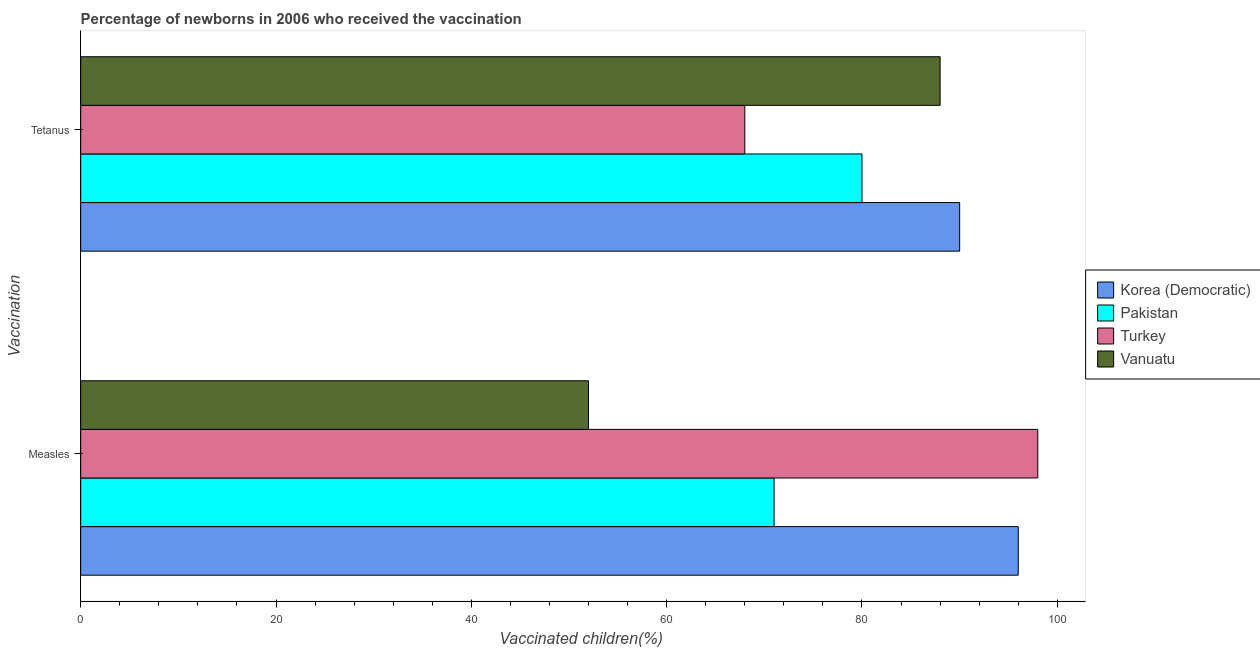How many different coloured bars are there?
Keep it short and to the point. 4. How many groups of bars are there?
Offer a very short reply. 2. How many bars are there on the 1st tick from the top?
Keep it short and to the point. 4. What is the label of the 1st group of bars from the top?
Make the answer very short. Tetanus. What is the percentage of newborns who received vaccination for measles in Korea (Democratic)?
Keep it short and to the point. 96. Across all countries, what is the maximum percentage of newborns who received vaccination for tetanus?
Your response must be concise. 90. Across all countries, what is the minimum percentage of newborns who received vaccination for tetanus?
Provide a short and direct response. 68. In which country was the percentage of newborns who received vaccination for tetanus maximum?
Make the answer very short. Korea (Democratic). What is the total percentage of newborns who received vaccination for tetanus in the graph?
Offer a terse response. 326. What is the difference between the percentage of newborns who received vaccination for measles in Vanuatu and that in Korea (Democratic)?
Provide a short and direct response. -44. What is the difference between the percentage of newborns who received vaccination for tetanus in Vanuatu and the percentage of newborns who received vaccination for measles in Pakistan?
Your answer should be compact. 17. What is the average percentage of newborns who received vaccination for tetanus per country?
Offer a very short reply. 81.5. What is the difference between the percentage of newborns who received vaccination for tetanus and percentage of newborns who received vaccination for measles in Vanuatu?
Make the answer very short. 36. In how many countries, is the percentage of newborns who received vaccination for measles greater than 84 %?
Your answer should be very brief. 2. What is the ratio of the percentage of newborns who received vaccination for measles in Pakistan to that in Turkey?
Offer a very short reply. 0.72. Is the percentage of newborns who received vaccination for measles in Turkey less than that in Korea (Democratic)?
Give a very brief answer. No. In how many countries, is the percentage of newborns who received vaccination for tetanus greater than the average percentage of newborns who received vaccination for tetanus taken over all countries?
Keep it short and to the point. 2. What does the 2nd bar from the top in Tetanus represents?
Keep it short and to the point. Turkey. What does the 1st bar from the bottom in Measles represents?
Offer a terse response. Korea (Democratic). How many bars are there?
Your answer should be compact. 8. Are all the bars in the graph horizontal?
Ensure brevity in your answer.  Yes. What is the difference between two consecutive major ticks on the X-axis?
Give a very brief answer. 20. Are the values on the major ticks of X-axis written in scientific E-notation?
Offer a terse response. No. How many legend labels are there?
Your answer should be compact. 4. How are the legend labels stacked?
Your answer should be very brief. Vertical. What is the title of the graph?
Provide a short and direct response. Percentage of newborns in 2006 who received the vaccination. What is the label or title of the X-axis?
Ensure brevity in your answer.  Vaccinated children(%)
. What is the label or title of the Y-axis?
Give a very brief answer. Vaccination. What is the Vaccinated children(%)
 of Korea (Democratic) in Measles?
Provide a succinct answer. 96. What is the Vaccinated children(%)
 in Pakistan in Measles?
Give a very brief answer. 71. What is the Vaccinated children(%)
 of Vanuatu in Measles?
Your answer should be compact. 52. What is the Vaccinated children(%)
 of Pakistan in Tetanus?
Provide a short and direct response. 80. Across all Vaccination, what is the maximum Vaccinated children(%)
 of Korea (Democratic)?
Your response must be concise. 96. Across all Vaccination, what is the maximum Vaccinated children(%)
 of Pakistan?
Offer a very short reply. 80. Across all Vaccination, what is the maximum Vaccinated children(%)
 of Turkey?
Provide a short and direct response. 98. What is the total Vaccinated children(%)
 in Korea (Democratic) in the graph?
Give a very brief answer. 186. What is the total Vaccinated children(%)
 of Pakistan in the graph?
Your answer should be very brief. 151. What is the total Vaccinated children(%)
 in Turkey in the graph?
Your answer should be compact. 166. What is the total Vaccinated children(%)
 in Vanuatu in the graph?
Give a very brief answer. 140. What is the difference between the Vaccinated children(%)
 of Korea (Democratic) in Measles and that in Tetanus?
Provide a succinct answer. 6. What is the difference between the Vaccinated children(%)
 in Pakistan in Measles and that in Tetanus?
Ensure brevity in your answer.  -9. What is the difference between the Vaccinated children(%)
 in Vanuatu in Measles and that in Tetanus?
Provide a short and direct response. -36. What is the difference between the Vaccinated children(%)
 of Korea (Democratic) in Measles and the Vaccinated children(%)
 of Pakistan in Tetanus?
Give a very brief answer. 16. What is the difference between the Vaccinated children(%)
 in Korea (Democratic) in Measles and the Vaccinated children(%)
 in Turkey in Tetanus?
Your response must be concise. 28. What is the average Vaccinated children(%)
 of Korea (Democratic) per Vaccination?
Give a very brief answer. 93. What is the average Vaccinated children(%)
 in Pakistan per Vaccination?
Give a very brief answer. 75.5. What is the average Vaccinated children(%)
 of Turkey per Vaccination?
Offer a very short reply. 83. What is the average Vaccinated children(%)
 in Vanuatu per Vaccination?
Your response must be concise. 70. What is the difference between the Vaccinated children(%)
 of Korea (Democratic) and Vaccinated children(%)
 of Pakistan in Measles?
Your answer should be compact. 25. What is the difference between the Vaccinated children(%)
 of Korea (Democratic) and Vaccinated children(%)
 of Vanuatu in Measles?
Provide a succinct answer. 44. What is the difference between the Vaccinated children(%)
 of Korea (Democratic) and Vaccinated children(%)
 of Turkey in Tetanus?
Make the answer very short. 22. What is the difference between the Vaccinated children(%)
 in Korea (Democratic) and Vaccinated children(%)
 in Vanuatu in Tetanus?
Provide a succinct answer. 2. What is the difference between the Vaccinated children(%)
 of Pakistan and Vaccinated children(%)
 of Vanuatu in Tetanus?
Offer a very short reply. -8. What is the ratio of the Vaccinated children(%)
 in Korea (Democratic) in Measles to that in Tetanus?
Give a very brief answer. 1.07. What is the ratio of the Vaccinated children(%)
 of Pakistan in Measles to that in Tetanus?
Your answer should be compact. 0.89. What is the ratio of the Vaccinated children(%)
 of Turkey in Measles to that in Tetanus?
Make the answer very short. 1.44. What is the ratio of the Vaccinated children(%)
 of Vanuatu in Measles to that in Tetanus?
Give a very brief answer. 0.59. What is the difference between the highest and the second highest Vaccinated children(%)
 in Korea (Democratic)?
Ensure brevity in your answer.  6. What is the difference between the highest and the second highest Vaccinated children(%)
 in Pakistan?
Keep it short and to the point. 9. What is the difference between the highest and the second highest Vaccinated children(%)
 of Turkey?
Your answer should be very brief. 30. What is the difference between the highest and the second highest Vaccinated children(%)
 in Vanuatu?
Provide a short and direct response. 36. What is the difference between the highest and the lowest Vaccinated children(%)
 in Korea (Democratic)?
Make the answer very short. 6. What is the difference between the highest and the lowest Vaccinated children(%)
 of Pakistan?
Provide a short and direct response. 9. 